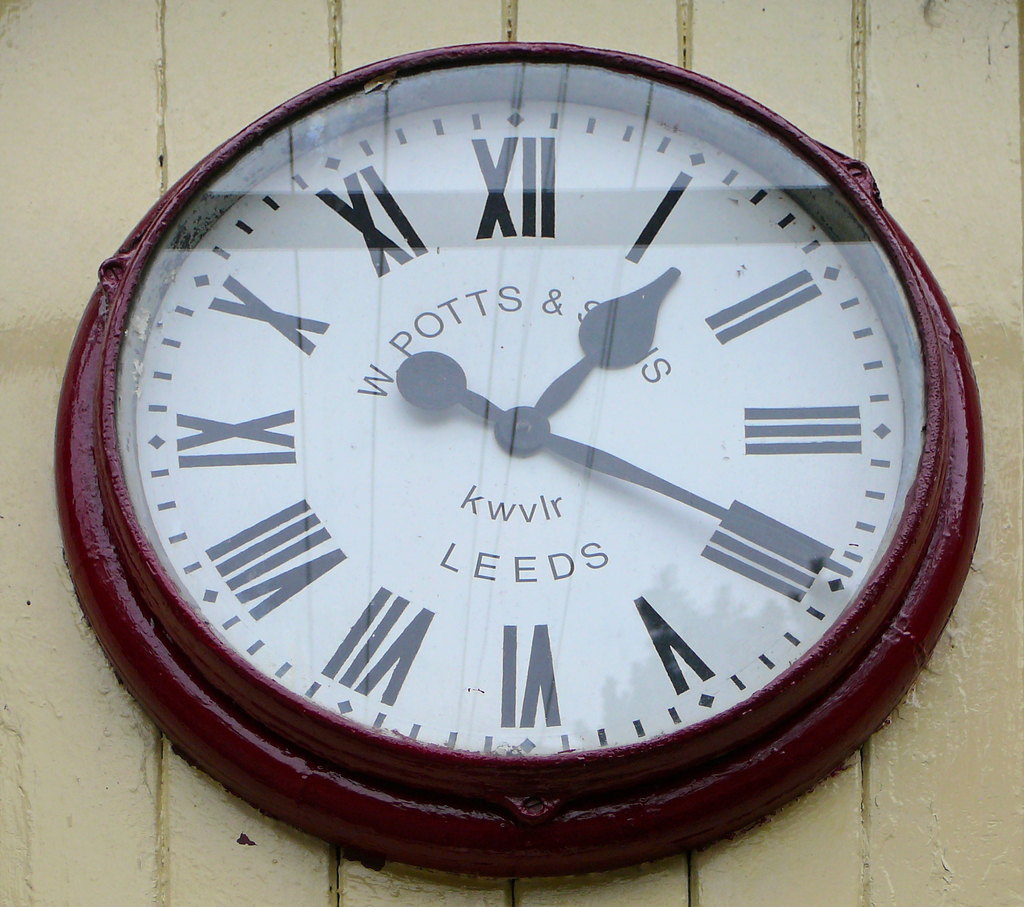Provide a one-sentence caption for the provided image.
Reference OCR token: POTTS, &, S, kwvlr, LEEDS, IA A W Potts and Son's clock displaying the time. 